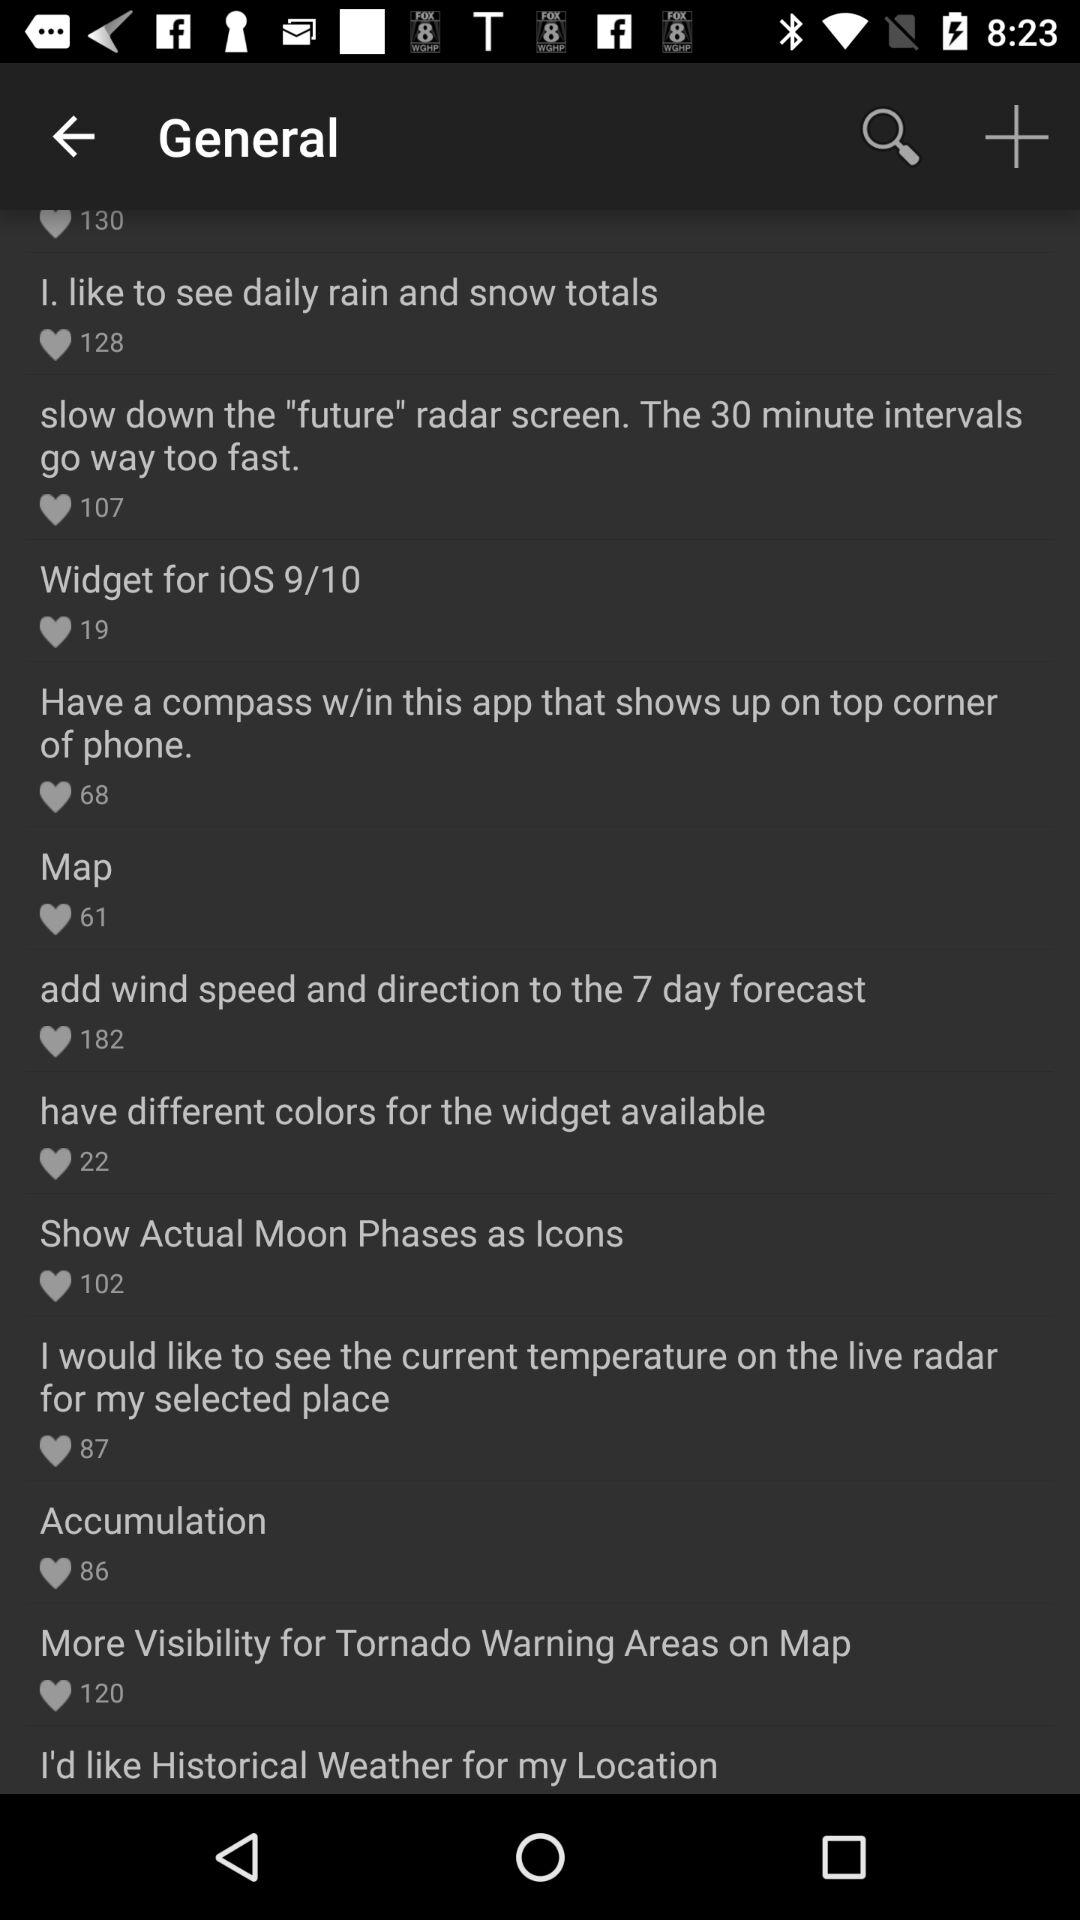Which topic has 22 likes? The topic is "have different colors for the widget available". 